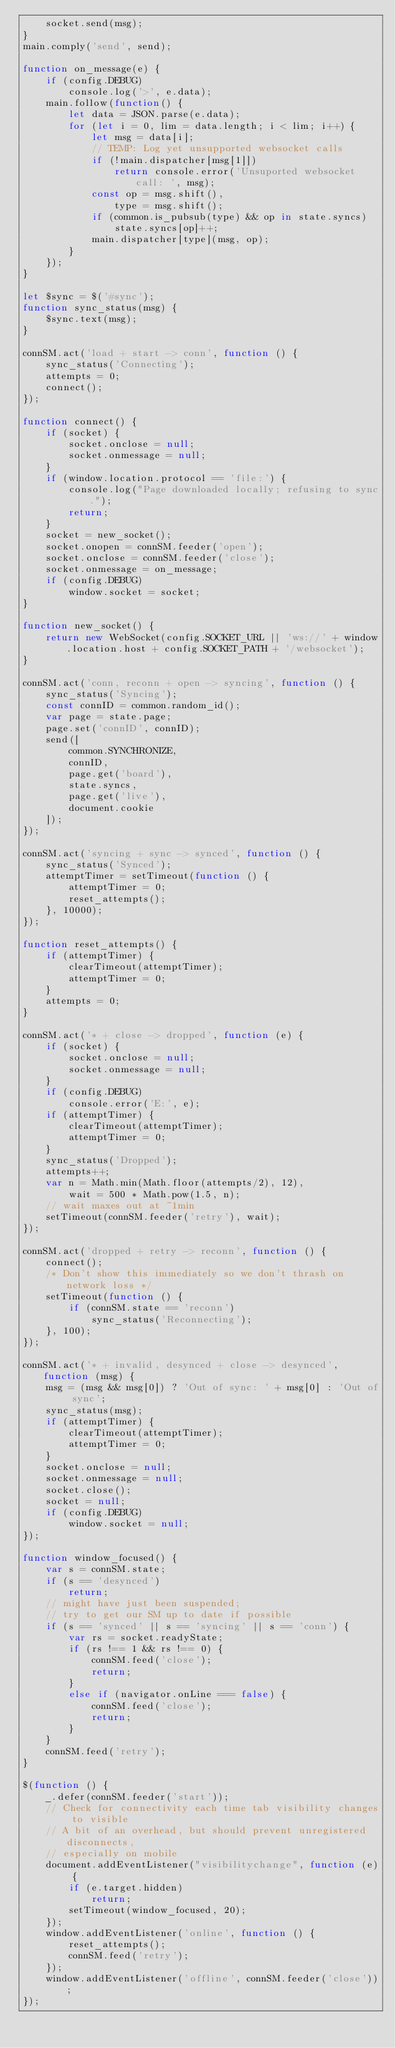<code> <loc_0><loc_0><loc_500><loc_500><_JavaScript_>	socket.send(msg);
}
main.comply('send', send);

function on_message(e) {
	if (config.DEBUG)
		console.log('>', e.data);
	main.follow(function() {
		let data = JSON.parse(e.data);
		for (let i = 0, lim = data.length; i < lim; i++) {
			let msg = data[i];
			// TEMP: Log yet unsupported websocket calls
			if (!main.dispatcher[msg[1]])
				return console.error('Unsuported websocket call: ', msg);
			const op = msg.shift(),
				type = msg.shift();
			if (common.is_pubsub(type) && op in state.syncs)
				state.syncs[op]++;
			main.dispatcher[type](msg, op);
		}
	});
}

let $sync = $('#sync');
function sync_status(msg) {
	$sync.text(msg);
}

connSM.act('load + start -> conn', function () {
	sync_status('Connecting');
	attempts = 0;
	connect();
});

function connect() {
	if (socket) {
		socket.onclose = null;
		socket.onmessage = null;
	}
	if (window.location.protocol == 'file:') {
		console.log("Page downloaded locally; refusing to sync.");
		return;
	}
	socket = new_socket();
	socket.onopen = connSM.feeder('open');
	socket.onclose = connSM.feeder('close');
	socket.onmessage = on_message;
	if (config.DEBUG)
		window.socket = socket;
}

function new_socket() {
	return new WebSocket(config.SOCKET_URL || 'ws://' + window.location.host + config.SOCKET_PATH + '/websocket');
}

connSM.act('conn, reconn + open -> syncing', function () {
	sync_status('Syncing');
	const connID = common.random_id();
	var page = state.page;
	page.set('connID', connID);
	send([
		common.SYNCHRONIZE,
		connID,
		page.get('board'),
		state.syncs,
		page.get('live'),
		document.cookie
	]);
});

connSM.act('syncing + sync -> synced', function () {
	sync_status('Synced');
	attemptTimer = setTimeout(function () {
		attemptTimer = 0;
		reset_attempts();
	}, 10000);
});

function reset_attempts() {
	if (attemptTimer) {
		clearTimeout(attemptTimer);
		attemptTimer = 0;
	}
	attempts = 0;
}

connSM.act('* + close -> dropped', function (e) {
	if (socket) {
		socket.onclose = null;
		socket.onmessage = null;
	}
	if (config.DEBUG)
		console.error('E:', e);
	if (attemptTimer) {
		clearTimeout(attemptTimer);
		attemptTimer = 0;
	}
	sync_status('Dropped');
	attempts++;
	var n = Math.min(Math.floor(attempts/2), 12),
		wait = 500 * Math.pow(1.5, n);
	// wait maxes out at ~1min
	setTimeout(connSM.feeder('retry'), wait);
});

connSM.act('dropped + retry -> reconn', function () {
	connect();
	/* Don't show this immediately so we don't thrash on network loss */
	setTimeout(function () {
		if (connSM.state == 'reconn')
			sync_status('Reconnecting');
	}, 100);
});

connSM.act('* + invalid, desynced + close -> desynced', function (msg) {
	msg = (msg && msg[0]) ? 'Out of sync: ' + msg[0] : 'Out of sync';
	sync_status(msg);
	if (attemptTimer) {
		clearTimeout(attemptTimer);
		attemptTimer = 0;
	}
	socket.onclose = null;
	socket.onmessage = null;
	socket.close();
	socket = null;
	if (config.DEBUG)
		window.socket = null;
});

function window_focused() {
	var s = connSM.state;
	if (s == 'desynced')
		return;
	// might have just been suspended;
	// try to get our SM up to date if possible
	if (s == 'synced' || s == 'syncing' || s == 'conn') {
		var rs = socket.readyState;
		if (rs !== 1 && rs !== 0) {
			connSM.feed('close');
			return;
		}
		else if (navigator.onLine === false) {
			connSM.feed('close');
			return;
		}
	}
	connSM.feed('retry');
}

$(function () {
	_.defer(connSM.feeder('start'));
	// Check for connectivity each time tab visibility changes to visible
	// A bit of an overhead, but should prevent unregistered disconnects,
	// especially on mobile
	document.addEventListener("visibilitychange", function (e) {
		if (e.target.hidden)
			return;
		setTimeout(window_focused, 20);
	});
	window.addEventListener('online', function () {
		reset_attempts();
		connSM.feed('retry');
	});
	window.addEventListener('offline', connSM.feeder('close'));
});
</code> 